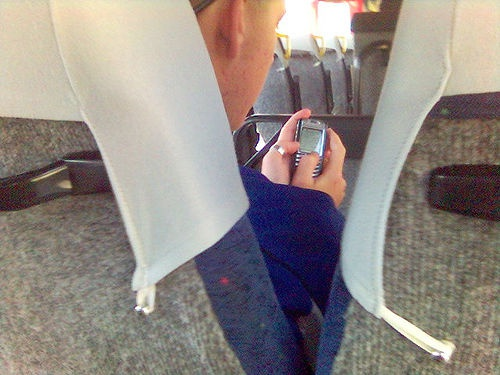Describe the objects in this image and their specific colors. I can see people in lightgray, navy, brown, and tan tones and cell phone in lightgray, darkgray, and gray tones in this image. 